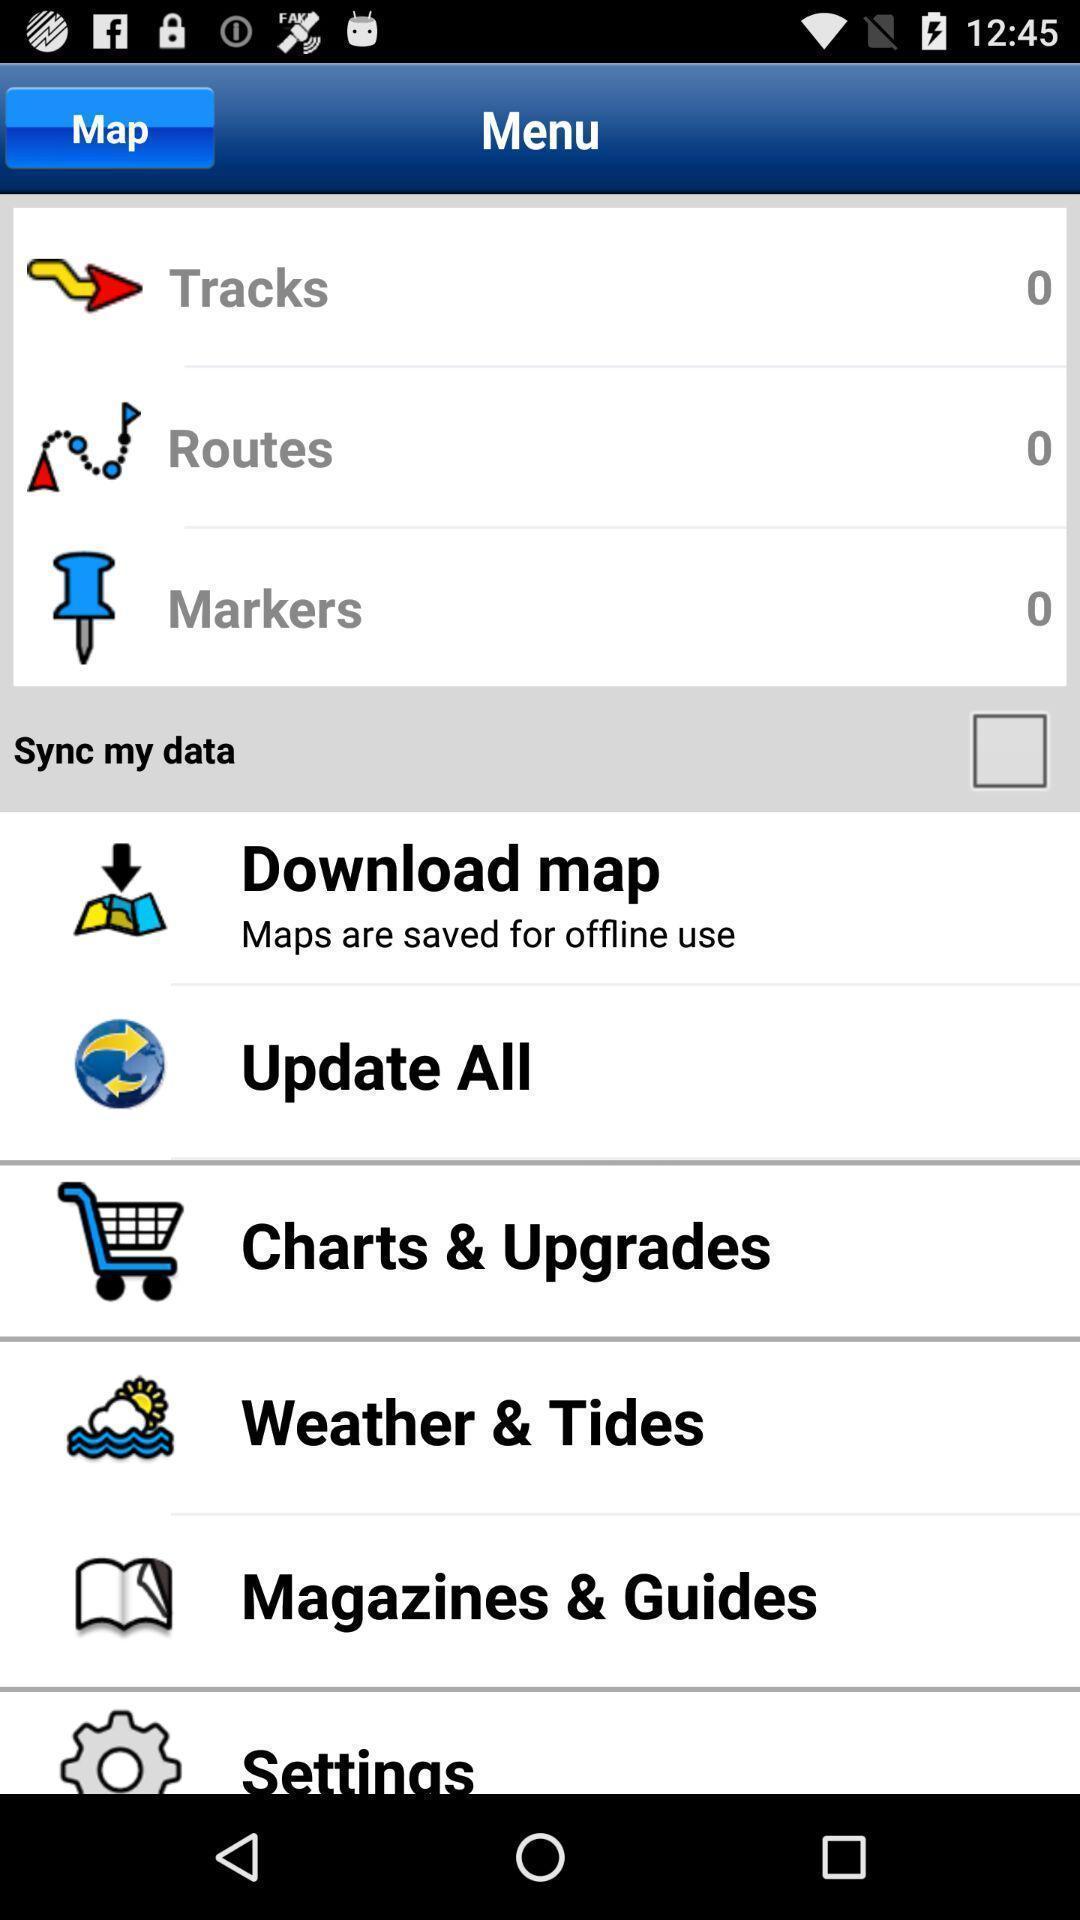Tell me what you see in this picture. Screen displaying the menu page. 